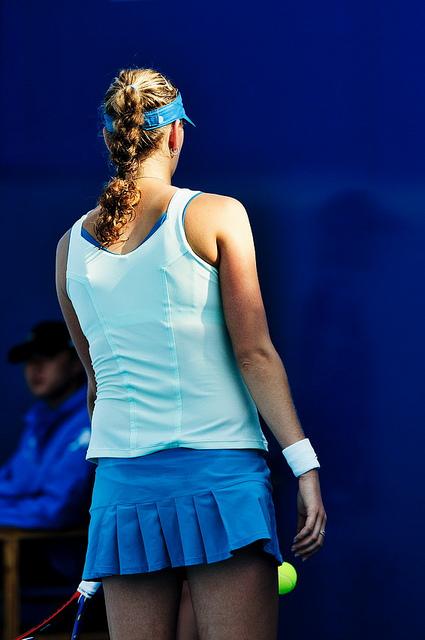What brand is her skirt?
Short answer required. Nike. What color is her skirt?
Short answer required. Blue. What is on the woman's rear end?
Quick response, please. Skirt. What color is the players visor?
Keep it brief. Blue. What color is the woman's skirt?
Short answer required. Blue. What sport is she playing?
Short answer required. Tennis. 